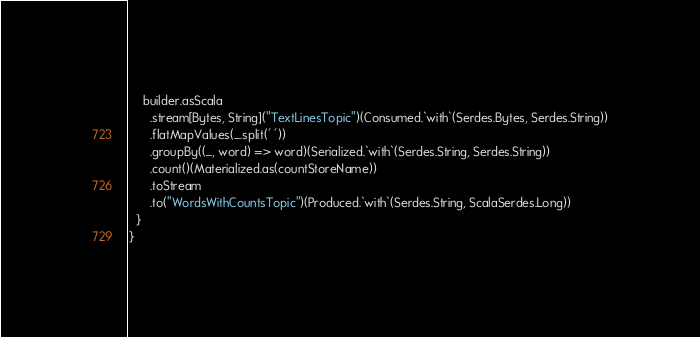Convert code to text. <code><loc_0><loc_0><loc_500><loc_500><_Scala_>    builder.asScala
      .stream[Bytes, String]("TextLinesTopic")(Consumed.`with`(Serdes.Bytes, Serdes.String))
      .flatMapValues(_.split(' '))
      .groupBy((_, word) => word)(Serialized.`with`(Serdes.String, Serdes.String))
      .count()(Materialized.as(countStoreName))
      .toStream
      .to("WordsWithCountsTopic")(Produced.`with`(Serdes.String, ScalaSerdes.Long))
  }
}
</code> 